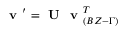<formula> <loc_0><loc_0><loc_500><loc_500>v ^ { \prime } = U v _ { ( B Z - \Gamma ) } ^ { T }</formula> 